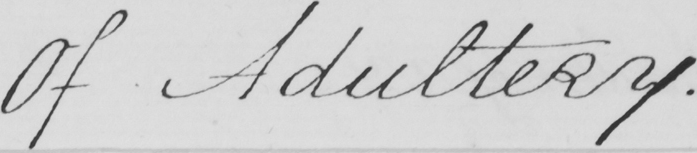What is written in this line of handwriting? Of Adultery . 